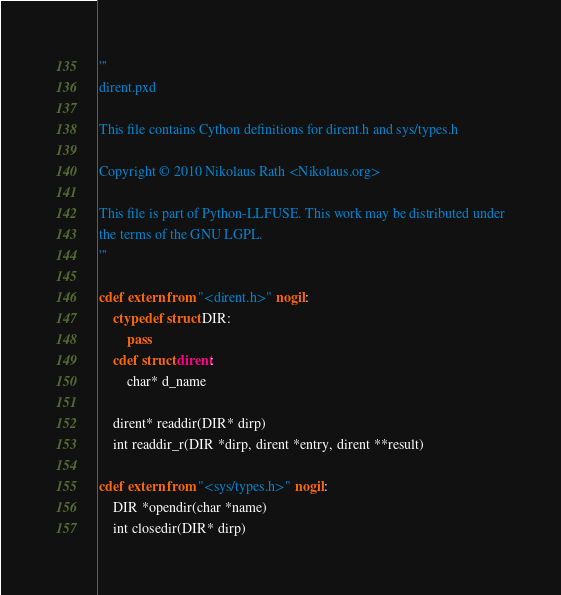<code> <loc_0><loc_0><loc_500><loc_500><_Cython_>'''
dirent.pxd

This file contains Cython definitions for dirent.h and sys/types.h

Copyright © 2010 Nikolaus Rath <Nikolaus.org>

This file is part of Python-LLFUSE. This work may be distributed under
the terms of the GNU LGPL.
'''

cdef extern from "<dirent.h>" nogil:
    ctypedef struct DIR:
        pass
    cdef struct dirent:
        char* d_name

    dirent* readdir(DIR* dirp)
    int readdir_r(DIR *dirp, dirent *entry, dirent **result)

cdef extern from "<sys/types.h>" nogil:
    DIR *opendir(char *name)
    int closedir(DIR* dirp)
</code> 